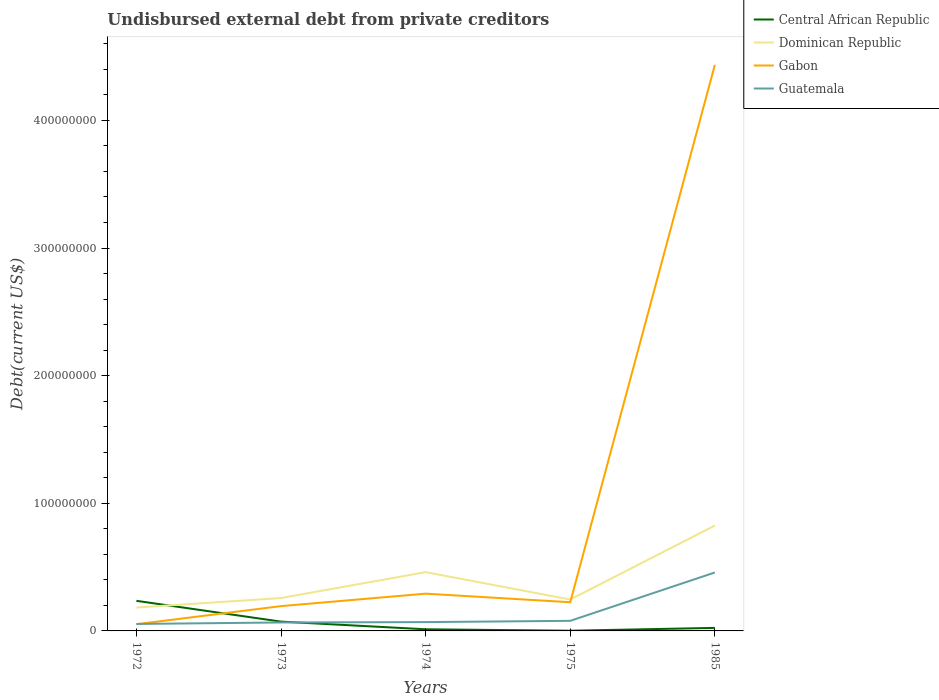Does the line corresponding to Central African Republic intersect with the line corresponding to Guatemala?
Make the answer very short. Yes. Across all years, what is the maximum total debt in Gabon?
Provide a short and direct response. 5.24e+06. What is the total total debt in Central African Republic in the graph?
Provide a short and direct response. 1.12e+06. What is the difference between the highest and the second highest total debt in Guatemala?
Offer a very short reply. 4.03e+07. What is the difference between the highest and the lowest total debt in Guatemala?
Your response must be concise. 1. Is the total debt in Central African Republic strictly greater than the total debt in Gabon over the years?
Ensure brevity in your answer.  No. How many lines are there?
Keep it short and to the point. 4. What is the difference between two consecutive major ticks on the Y-axis?
Provide a succinct answer. 1.00e+08. Does the graph contain grids?
Your response must be concise. No. Where does the legend appear in the graph?
Provide a succinct answer. Top right. How many legend labels are there?
Provide a succinct answer. 4. What is the title of the graph?
Provide a short and direct response. Undisbursed external debt from private creditors. Does "Central African Republic" appear as one of the legend labels in the graph?
Keep it short and to the point. Yes. What is the label or title of the Y-axis?
Your response must be concise. Debt(current US$). What is the Debt(current US$) of Central African Republic in 1972?
Your response must be concise. 2.36e+07. What is the Debt(current US$) in Dominican Republic in 1972?
Ensure brevity in your answer.  1.83e+07. What is the Debt(current US$) in Gabon in 1972?
Your answer should be very brief. 5.24e+06. What is the Debt(current US$) in Guatemala in 1972?
Provide a short and direct response. 5.46e+06. What is the Debt(current US$) of Central African Republic in 1973?
Provide a short and direct response. 7.28e+06. What is the Debt(current US$) in Dominican Republic in 1973?
Your answer should be compact. 2.58e+07. What is the Debt(current US$) of Gabon in 1973?
Offer a very short reply. 1.94e+07. What is the Debt(current US$) in Guatemala in 1973?
Offer a terse response. 6.62e+06. What is the Debt(current US$) in Central African Republic in 1974?
Provide a short and direct response. 1.28e+06. What is the Debt(current US$) of Dominican Republic in 1974?
Provide a short and direct response. 4.61e+07. What is the Debt(current US$) in Gabon in 1974?
Offer a terse response. 2.92e+07. What is the Debt(current US$) in Guatemala in 1974?
Make the answer very short. 6.90e+06. What is the Debt(current US$) in Central African Republic in 1975?
Give a very brief answer. 1.62e+05. What is the Debt(current US$) in Dominican Republic in 1975?
Keep it short and to the point. 2.46e+07. What is the Debt(current US$) in Gabon in 1975?
Offer a terse response. 2.25e+07. What is the Debt(current US$) in Guatemala in 1975?
Your answer should be very brief. 7.91e+06. What is the Debt(current US$) of Central African Republic in 1985?
Ensure brevity in your answer.  2.37e+06. What is the Debt(current US$) in Dominican Republic in 1985?
Ensure brevity in your answer.  8.26e+07. What is the Debt(current US$) in Gabon in 1985?
Keep it short and to the point. 4.44e+08. What is the Debt(current US$) of Guatemala in 1985?
Offer a very short reply. 4.58e+07. Across all years, what is the maximum Debt(current US$) of Central African Republic?
Ensure brevity in your answer.  2.36e+07. Across all years, what is the maximum Debt(current US$) of Dominican Republic?
Ensure brevity in your answer.  8.26e+07. Across all years, what is the maximum Debt(current US$) of Gabon?
Your response must be concise. 4.44e+08. Across all years, what is the maximum Debt(current US$) of Guatemala?
Provide a short and direct response. 4.58e+07. Across all years, what is the minimum Debt(current US$) in Central African Republic?
Give a very brief answer. 1.62e+05. Across all years, what is the minimum Debt(current US$) in Dominican Republic?
Make the answer very short. 1.83e+07. Across all years, what is the minimum Debt(current US$) of Gabon?
Keep it short and to the point. 5.24e+06. Across all years, what is the minimum Debt(current US$) of Guatemala?
Offer a terse response. 5.46e+06. What is the total Debt(current US$) of Central African Republic in the graph?
Keep it short and to the point. 3.47e+07. What is the total Debt(current US$) in Dominican Republic in the graph?
Ensure brevity in your answer.  1.97e+08. What is the total Debt(current US$) of Gabon in the graph?
Your answer should be very brief. 5.20e+08. What is the total Debt(current US$) in Guatemala in the graph?
Ensure brevity in your answer.  7.27e+07. What is the difference between the Debt(current US$) of Central African Republic in 1972 and that in 1973?
Offer a terse response. 1.63e+07. What is the difference between the Debt(current US$) of Dominican Republic in 1972 and that in 1973?
Give a very brief answer. -7.46e+06. What is the difference between the Debt(current US$) of Gabon in 1972 and that in 1973?
Your answer should be very brief. -1.42e+07. What is the difference between the Debt(current US$) in Guatemala in 1972 and that in 1973?
Your answer should be very brief. -1.16e+06. What is the difference between the Debt(current US$) of Central African Republic in 1972 and that in 1974?
Your answer should be compact. 2.23e+07. What is the difference between the Debt(current US$) in Dominican Republic in 1972 and that in 1974?
Your answer should be compact. -2.77e+07. What is the difference between the Debt(current US$) of Gabon in 1972 and that in 1974?
Ensure brevity in your answer.  -2.40e+07. What is the difference between the Debt(current US$) of Guatemala in 1972 and that in 1974?
Your response must be concise. -1.44e+06. What is the difference between the Debt(current US$) in Central African Republic in 1972 and that in 1975?
Keep it short and to the point. 2.34e+07. What is the difference between the Debt(current US$) in Dominican Republic in 1972 and that in 1975?
Your response must be concise. -6.30e+06. What is the difference between the Debt(current US$) of Gabon in 1972 and that in 1975?
Ensure brevity in your answer.  -1.72e+07. What is the difference between the Debt(current US$) in Guatemala in 1972 and that in 1975?
Ensure brevity in your answer.  -2.44e+06. What is the difference between the Debt(current US$) in Central African Republic in 1972 and that in 1985?
Offer a very short reply. 2.12e+07. What is the difference between the Debt(current US$) in Dominican Republic in 1972 and that in 1985?
Provide a short and direct response. -6.43e+07. What is the difference between the Debt(current US$) in Gabon in 1972 and that in 1985?
Offer a very short reply. -4.38e+08. What is the difference between the Debt(current US$) of Guatemala in 1972 and that in 1985?
Ensure brevity in your answer.  -4.03e+07. What is the difference between the Debt(current US$) of Central African Republic in 1973 and that in 1974?
Your answer should be compact. 6.00e+06. What is the difference between the Debt(current US$) of Dominican Republic in 1973 and that in 1974?
Make the answer very short. -2.03e+07. What is the difference between the Debt(current US$) of Gabon in 1973 and that in 1974?
Your answer should be compact. -9.76e+06. What is the difference between the Debt(current US$) in Guatemala in 1973 and that in 1974?
Your response must be concise. -2.82e+05. What is the difference between the Debt(current US$) of Central African Republic in 1973 and that in 1975?
Keep it short and to the point. 7.12e+06. What is the difference between the Debt(current US$) in Dominican Republic in 1973 and that in 1975?
Provide a short and direct response. 1.16e+06. What is the difference between the Debt(current US$) of Gabon in 1973 and that in 1975?
Your answer should be compact. -3.05e+06. What is the difference between the Debt(current US$) of Guatemala in 1973 and that in 1975?
Your answer should be very brief. -1.29e+06. What is the difference between the Debt(current US$) of Central African Republic in 1973 and that in 1985?
Your answer should be compact. 4.91e+06. What is the difference between the Debt(current US$) in Dominican Republic in 1973 and that in 1985?
Make the answer very short. -5.68e+07. What is the difference between the Debt(current US$) in Gabon in 1973 and that in 1985?
Provide a succinct answer. -4.24e+08. What is the difference between the Debt(current US$) in Guatemala in 1973 and that in 1985?
Provide a succinct answer. -3.92e+07. What is the difference between the Debt(current US$) in Central African Republic in 1974 and that in 1975?
Provide a succinct answer. 1.12e+06. What is the difference between the Debt(current US$) of Dominican Republic in 1974 and that in 1975?
Make the answer very short. 2.14e+07. What is the difference between the Debt(current US$) of Gabon in 1974 and that in 1975?
Provide a succinct answer. 6.71e+06. What is the difference between the Debt(current US$) of Guatemala in 1974 and that in 1975?
Your answer should be compact. -1.01e+06. What is the difference between the Debt(current US$) in Central African Republic in 1974 and that in 1985?
Provide a succinct answer. -1.09e+06. What is the difference between the Debt(current US$) in Dominican Republic in 1974 and that in 1985?
Give a very brief answer. -3.65e+07. What is the difference between the Debt(current US$) of Gabon in 1974 and that in 1985?
Make the answer very short. -4.14e+08. What is the difference between the Debt(current US$) of Guatemala in 1974 and that in 1985?
Make the answer very short. -3.89e+07. What is the difference between the Debt(current US$) in Central African Republic in 1975 and that in 1985?
Your response must be concise. -2.21e+06. What is the difference between the Debt(current US$) in Dominican Republic in 1975 and that in 1985?
Offer a very short reply. -5.80e+07. What is the difference between the Debt(current US$) of Gabon in 1975 and that in 1985?
Your answer should be very brief. -4.21e+08. What is the difference between the Debt(current US$) in Guatemala in 1975 and that in 1985?
Your answer should be very brief. -3.79e+07. What is the difference between the Debt(current US$) in Central African Republic in 1972 and the Debt(current US$) in Dominican Republic in 1973?
Offer a terse response. -2.19e+06. What is the difference between the Debt(current US$) in Central African Republic in 1972 and the Debt(current US$) in Gabon in 1973?
Offer a terse response. 4.15e+06. What is the difference between the Debt(current US$) of Central African Republic in 1972 and the Debt(current US$) of Guatemala in 1973?
Ensure brevity in your answer.  1.70e+07. What is the difference between the Debt(current US$) in Dominican Republic in 1972 and the Debt(current US$) in Gabon in 1973?
Make the answer very short. -1.12e+06. What is the difference between the Debt(current US$) in Dominican Republic in 1972 and the Debt(current US$) in Guatemala in 1973?
Ensure brevity in your answer.  1.17e+07. What is the difference between the Debt(current US$) in Gabon in 1972 and the Debt(current US$) in Guatemala in 1973?
Offer a very short reply. -1.38e+06. What is the difference between the Debt(current US$) in Central African Republic in 1972 and the Debt(current US$) in Dominican Republic in 1974?
Your answer should be compact. -2.25e+07. What is the difference between the Debt(current US$) in Central African Republic in 1972 and the Debt(current US$) in Gabon in 1974?
Your answer should be compact. -5.61e+06. What is the difference between the Debt(current US$) of Central African Republic in 1972 and the Debt(current US$) of Guatemala in 1974?
Ensure brevity in your answer.  1.67e+07. What is the difference between the Debt(current US$) in Dominican Republic in 1972 and the Debt(current US$) in Gabon in 1974?
Provide a succinct answer. -1.09e+07. What is the difference between the Debt(current US$) of Dominican Republic in 1972 and the Debt(current US$) of Guatemala in 1974?
Ensure brevity in your answer.  1.14e+07. What is the difference between the Debt(current US$) of Gabon in 1972 and the Debt(current US$) of Guatemala in 1974?
Ensure brevity in your answer.  -1.66e+06. What is the difference between the Debt(current US$) of Central African Republic in 1972 and the Debt(current US$) of Dominican Republic in 1975?
Give a very brief answer. -1.03e+06. What is the difference between the Debt(current US$) of Central African Republic in 1972 and the Debt(current US$) of Gabon in 1975?
Make the answer very short. 1.10e+06. What is the difference between the Debt(current US$) of Central African Republic in 1972 and the Debt(current US$) of Guatemala in 1975?
Make the answer very short. 1.57e+07. What is the difference between the Debt(current US$) of Dominican Republic in 1972 and the Debt(current US$) of Gabon in 1975?
Your answer should be very brief. -4.17e+06. What is the difference between the Debt(current US$) of Dominican Republic in 1972 and the Debt(current US$) of Guatemala in 1975?
Offer a very short reply. 1.04e+07. What is the difference between the Debt(current US$) of Gabon in 1972 and the Debt(current US$) of Guatemala in 1975?
Give a very brief answer. -2.66e+06. What is the difference between the Debt(current US$) in Central African Republic in 1972 and the Debt(current US$) in Dominican Republic in 1985?
Offer a terse response. -5.90e+07. What is the difference between the Debt(current US$) of Central African Republic in 1972 and the Debt(current US$) of Gabon in 1985?
Provide a succinct answer. -4.20e+08. What is the difference between the Debt(current US$) of Central African Republic in 1972 and the Debt(current US$) of Guatemala in 1985?
Your answer should be very brief. -2.22e+07. What is the difference between the Debt(current US$) of Dominican Republic in 1972 and the Debt(current US$) of Gabon in 1985?
Make the answer very short. -4.25e+08. What is the difference between the Debt(current US$) in Dominican Republic in 1972 and the Debt(current US$) in Guatemala in 1985?
Provide a short and direct response. -2.75e+07. What is the difference between the Debt(current US$) in Gabon in 1972 and the Debt(current US$) in Guatemala in 1985?
Your response must be concise. -4.05e+07. What is the difference between the Debt(current US$) in Central African Republic in 1973 and the Debt(current US$) in Dominican Republic in 1974?
Provide a succinct answer. -3.88e+07. What is the difference between the Debt(current US$) in Central African Republic in 1973 and the Debt(current US$) in Gabon in 1974?
Your answer should be compact. -2.19e+07. What is the difference between the Debt(current US$) of Central African Republic in 1973 and the Debt(current US$) of Guatemala in 1974?
Keep it short and to the point. 3.81e+05. What is the difference between the Debt(current US$) of Dominican Republic in 1973 and the Debt(current US$) of Gabon in 1974?
Keep it short and to the point. -3.42e+06. What is the difference between the Debt(current US$) of Dominican Republic in 1973 and the Debt(current US$) of Guatemala in 1974?
Make the answer very short. 1.89e+07. What is the difference between the Debt(current US$) in Gabon in 1973 and the Debt(current US$) in Guatemala in 1974?
Make the answer very short. 1.25e+07. What is the difference between the Debt(current US$) of Central African Republic in 1973 and the Debt(current US$) of Dominican Republic in 1975?
Your response must be concise. -1.73e+07. What is the difference between the Debt(current US$) of Central African Republic in 1973 and the Debt(current US$) of Gabon in 1975?
Your answer should be compact. -1.52e+07. What is the difference between the Debt(current US$) of Central African Republic in 1973 and the Debt(current US$) of Guatemala in 1975?
Provide a succinct answer. -6.26e+05. What is the difference between the Debt(current US$) of Dominican Republic in 1973 and the Debt(current US$) of Gabon in 1975?
Keep it short and to the point. 3.29e+06. What is the difference between the Debt(current US$) in Dominican Republic in 1973 and the Debt(current US$) in Guatemala in 1975?
Offer a very short reply. 1.79e+07. What is the difference between the Debt(current US$) in Gabon in 1973 and the Debt(current US$) in Guatemala in 1975?
Give a very brief answer. 1.15e+07. What is the difference between the Debt(current US$) in Central African Republic in 1973 and the Debt(current US$) in Dominican Republic in 1985?
Make the answer very short. -7.53e+07. What is the difference between the Debt(current US$) of Central African Republic in 1973 and the Debt(current US$) of Gabon in 1985?
Give a very brief answer. -4.36e+08. What is the difference between the Debt(current US$) in Central African Republic in 1973 and the Debt(current US$) in Guatemala in 1985?
Your answer should be compact. -3.85e+07. What is the difference between the Debt(current US$) of Dominican Republic in 1973 and the Debt(current US$) of Gabon in 1985?
Your answer should be compact. -4.18e+08. What is the difference between the Debt(current US$) of Dominican Republic in 1973 and the Debt(current US$) of Guatemala in 1985?
Give a very brief answer. -2.00e+07. What is the difference between the Debt(current US$) of Gabon in 1973 and the Debt(current US$) of Guatemala in 1985?
Your answer should be compact. -2.64e+07. What is the difference between the Debt(current US$) in Central African Republic in 1974 and the Debt(current US$) in Dominican Republic in 1975?
Offer a terse response. -2.33e+07. What is the difference between the Debt(current US$) in Central African Republic in 1974 and the Debt(current US$) in Gabon in 1975?
Your answer should be compact. -2.12e+07. What is the difference between the Debt(current US$) of Central African Republic in 1974 and the Debt(current US$) of Guatemala in 1975?
Your response must be concise. -6.62e+06. What is the difference between the Debt(current US$) in Dominican Republic in 1974 and the Debt(current US$) in Gabon in 1975?
Provide a short and direct response. 2.36e+07. What is the difference between the Debt(current US$) in Dominican Republic in 1974 and the Debt(current US$) in Guatemala in 1975?
Your answer should be compact. 3.81e+07. What is the difference between the Debt(current US$) in Gabon in 1974 and the Debt(current US$) in Guatemala in 1975?
Your answer should be very brief. 2.13e+07. What is the difference between the Debt(current US$) of Central African Republic in 1974 and the Debt(current US$) of Dominican Republic in 1985?
Give a very brief answer. -8.13e+07. What is the difference between the Debt(current US$) of Central African Republic in 1974 and the Debt(current US$) of Gabon in 1985?
Ensure brevity in your answer.  -4.42e+08. What is the difference between the Debt(current US$) of Central African Republic in 1974 and the Debt(current US$) of Guatemala in 1985?
Your answer should be very brief. -4.45e+07. What is the difference between the Debt(current US$) in Dominican Republic in 1974 and the Debt(current US$) in Gabon in 1985?
Make the answer very short. -3.97e+08. What is the difference between the Debt(current US$) in Dominican Republic in 1974 and the Debt(current US$) in Guatemala in 1985?
Keep it short and to the point. 2.63e+05. What is the difference between the Debt(current US$) in Gabon in 1974 and the Debt(current US$) in Guatemala in 1985?
Give a very brief answer. -1.66e+07. What is the difference between the Debt(current US$) of Central African Republic in 1975 and the Debt(current US$) of Dominican Republic in 1985?
Offer a terse response. -8.24e+07. What is the difference between the Debt(current US$) of Central African Republic in 1975 and the Debt(current US$) of Gabon in 1985?
Your answer should be very brief. -4.43e+08. What is the difference between the Debt(current US$) in Central African Republic in 1975 and the Debt(current US$) in Guatemala in 1985?
Offer a very short reply. -4.56e+07. What is the difference between the Debt(current US$) in Dominican Republic in 1975 and the Debt(current US$) in Gabon in 1985?
Your answer should be compact. -4.19e+08. What is the difference between the Debt(current US$) of Dominican Republic in 1975 and the Debt(current US$) of Guatemala in 1985?
Ensure brevity in your answer.  -2.12e+07. What is the difference between the Debt(current US$) of Gabon in 1975 and the Debt(current US$) of Guatemala in 1985?
Ensure brevity in your answer.  -2.33e+07. What is the average Debt(current US$) of Central African Republic per year?
Offer a terse response. 6.94e+06. What is the average Debt(current US$) in Dominican Republic per year?
Offer a very short reply. 3.95e+07. What is the average Debt(current US$) of Gabon per year?
Offer a very short reply. 1.04e+08. What is the average Debt(current US$) in Guatemala per year?
Offer a terse response. 1.45e+07. In the year 1972, what is the difference between the Debt(current US$) of Central African Republic and Debt(current US$) of Dominican Republic?
Your answer should be very brief. 5.27e+06. In the year 1972, what is the difference between the Debt(current US$) of Central African Republic and Debt(current US$) of Gabon?
Offer a very short reply. 1.83e+07. In the year 1972, what is the difference between the Debt(current US$) of Central African Republic and Debt(current US$) of Guatemala?
Ensure brevity in your answer.  1.81e+07. In the year 1972, what is the difference between the Debt(current US$) of Dominican Republic and Debt(current US$) of Gabon?
Provide a short and direct response. 1.31e+07. In the year 1972, what is the difference between the Debt(current US$) in Dominican Republic and Debt(current US$) in Guatemala?
Keep it short and to the point. 1.29e+07. In the year 1973, what is the difference between the Debt(current US$) of Central African Republic and Debt(current US$) of Dominican Republic?
Your answer should be very brief. -1.85e+07. In the year 1973, what is the difference between the Debt(current US$) in Central African Republic and Debt(current US$) in Gabon?
Provide a short and direct response. -1.22e+07. In the year 1973, what is the difference between the Debt(current US$) of Central African Republic and Debt(current US$) of Guatemala?
Keep it short and to the point. 6.63e+05. In the year 1973, what is the difference between the Debt(current US$) in Dominican Republic and Debt(current US$) in Gabon?
Offer a terse response. 6.34e+06. In the year 1973, what is the difference between the Debt(current US$) in Dominican Republic and Debt(current US$) in Guatemala?
Your answer should be compact. 1.92e+07. In the year 1973, what is the difference between the Debt(current US$) of Gabon and Debt(current US$) of Guatemala?
Offer a terse response. 1.28e+07. In the year 1974, what is the difference between the Debt(current US$) in Central African Republic and Debt(current US$) in Dominican Republic?
Give a very brief answer. -4.48e+07. In the year 1974, what is the difference between the Debt(current US$) of Central African Republic and Debt(current US$) of Gabon?
Ensure brevity in your answer.  -2.79e+07. In the year 1974, what is the difference between the Debt(current US$) in Central African Republic and Debt(current US$) in Guatemala?
Your answer should be very brief. -5.62e+06. In the year 1974, what is the difference between the Debt(current US$) in Dominican Republic and Debt(current US$) in Gabon?
Ensure brevity in your answer.  1.69e+07. In the year 1974, what is the difference between the Debt(current US$) of Dominican Republic and Debt(current US$) of Guatemala?
Ensure brevity in your answer.  3.91e+07. In the year 1974, what is the difference between the Debt(current US$) in Gabon and Debt(current US$) in Guatemala?
Give a very brief answer. 2.23e+07. In the year 1975, what is the difference between the Debt(current US$) of Central African Republic and Debt(current US$) of Dominican Republic?
Your answer should be very brief. -2.44e+07. In the year 1975, what is the difference between the Debt(current US$) in Central African Republic and Debt(current US$) in Gabon?
Your response must be concise. -2.23e+07. In the year 1975, what is the difference between the Debt(current US$) of Central African Republic and Debt(current US$) of Guatemala?
Make the answer very short. -7.75e+06. In the year 1975, what is the difference between the Debt(current US$) of Dominican Republic and Debt(current US$) of Gabon?
Offer a terse response. 2.13e+06. In the year 1975, what is the difference between the Debt(current US$) in Dominican Republic and Debt(current US$) in Guatemala?
Ensure brevity in your answer.  1.67e+07. In the year 1975, what is the difference between the Debt(current US$) in Gabon and Debt(current US$) in Guatemala?
Offer a terse response. 1.46e+07. In the year 1985, what is the difference between the Debt(current US$) in Central African Republic and Debt(current US$) in Dominican Republic?
Provide a short and direct response. -8.02e+07. In the year 1985, what is the difference between the Debt(current US$) of Central African Republic and Debt(current US$) of Gabon?
Offer a terse response. -4.41e+08. In the year 1985, what is the difference between the Debt(current US$) of Central African Republic and Debt(current US$) of Guatemala?
Offer a very short reply. -4.34e+07. In the year 1985, what is the difference between the Debt(current US$) of Dominican Republic and Debt(current US$) of Gabon?
Offer a terse response. -3.61e+08. In the year 1985, what is the difference between the Debt(current US$) of Dominican Republic and Debt(current US$) of Guatemala?
Offer a terse response. 3.68e+07. In the year 1985, what is the difference between the Debt(current US$) of Gabon and Debt(current US$) of Guatemala?
Give a very brief answer. 3.98e+08. What is the ratio of the Debt(current US$) of Central African Republic in 1972 to that in 1973?
Your answer should be compact. 3.24. What is the ratio of the Debt(current US$) of Dominican Republic in 1972 to that in 1973?
Offer a terse response. 0.71. What is the ratio of the Debt(current US$) in Gabon in 1972 to that in 1973?
Give a very brief answer. 0.27. What is the ratio of the Debt(current US$) of Guatemala in 1972 to that in 1973?
Keep it short and to the point. 0.83. What is the ratio of the Debt(current US$) in Central African Republic in 1972 to that in 1974?
Provide a short and direct response. 18.35. What is the ratio of the Debt(current US$) in Dominican Republic in 1972 to that in 1974?
Give a very brief answer. 0.4. What is the ratio of the Debt(current US$) of Gabon in 1972 to that in 1974?
Offer a terse response. 0.18. What is the ratio of the Debt(current US$) of Guatemala in 1972 to that in 1974?
Provide a short and direct response. 0.79. What is the ratio of the Debt(current US$) of Central African Republic in 1972 to that in 1975?
Your answer should be very brief. 145.59. What is the ratio of the Debt(current US$) of Dominican Republic in 1972 to that in 1975?
Provide a short and direct response. 0.74. What is the ratio of the Debt(current US$) of Gabon in 1972 to that in 1975?
Provide a succinct answer. 0.23. What is the ratio of the Debt(current US$) in Guatemala in 1972 to that in 1975?
Give a very brief answer. 0.69. What is the ratio of the Debt(current US$) in Central African Republic in 1972 to that in 1985?
Offer a very short reply. 9.94. What is the ratio of the Debt(current US$) in Dominican Republic in 1972 to that in 1985?
Provide a succinct answer. 0.22. What is the ratio of the Debt(current US$) in Gabon in 1972 to that in 1985?
Your answer should be compact. 0.01. What is the ratio of the Debt(current US$) of Guatemala in 1972 to that in 1985?
Provide a succinct answer. 0.12. What is the ratio of the Debt(current US$) of Central African Republic in 1973 to that in 1974?
Give a very brief answer. 5.67. What is the ratio of the Debt(current US$) in Dominican Republic in 1973 to that in 1974?
Offer a terse response. 0.56. What is the ratio of the Debt(current US$) of Gabon in 1973 to that in 1974?
Ensure brevity in your answer.  0.67. What is the ratio of the Debt(current US$) of Guatemala in 1973 to that in 1974?
Make the answer very short. 0.96. What is the ratio of the Debt(current US$) of Central African Republic in 1973 to that in 1975?
Keep it short and to the point. 44.96. What is the ratio of the Debt(current US$) of Dominican Republic in 1973 to that in 1975?
Ensure brevity in your answer.  1.05. What is the ratio of the Debt(current US$) of Gabon in 1973 to that in 1975?
Offer a terse response. 0.86. What is the ratio of the Debt(current US$) in Guatemala in 1973 to that in 1975?
Your response must be concise. 0.84. What is the ratio of the Debt(current US$) in Central African Republic in 1973 to that in 1985?
Offer a terse response. 3.07. What is the ratio of the Debt(current US$) of Dominican Republic in 1973 to that in 1985?
Your answer should be compact. 0.31. What is the ratio of the Debt(current US$) in Gabon in 1973 to that in 1985?
Your answer should be compact. 0.04. What is the ratio of the Debt(current US$) in Guatemala in 1973 to that in 1985?
Keep it short and to the point. 0.14. What is the ratio of the Debt(current US$) of Central African Republic in 1974 to that in 1975?
Offer a very short reply. 7.93. What is the ratio of the Debt(current US$) of Dominican Republic in 1974 to that in 1975?
Offer a terse response. 1.87. What is the ratio of the Debt(current US$) of Gabon in 1974 to that in 1975?
Ensure brevity in your answer.  1.3. What is the ratio of the Debt(current US$) of Guatemala in 1974 to that in 1975?
Your answer should be very brief. 0.87. What is the ratio of the Debt(current US$) of Central African Republic in 1974 to that in 1985?
Ensure brevity in your answer.  0.54. What is the ratio of the Debt(current US$) of Dominican Republic in 1974 to that in 1985?
Your response must be concise. 0.56. What is the ratio of the Debt(current US$) of Gabon in 1974 to that in 1985?
Your answer should be very brief. 0.07. What is the ratio of the Debt(current US$) in Guatemala in 1974 to that in 1985?
Your answer should be very brief. 0.15. What is the ratio of the Debt(current US$) of Central African Republic in 1975 to that in 1985?
Provide a succinct answer. 0.07. What is the ratio of the Debt(current US$) in Dominican Republic in 1975 to that in 1985?
Your answer should be very brief. 0.3. What is the ratio of the Debt(current US$) in Gabon in 1975 to that in 1985?
Offer a very short reply. 0.05. What is the ratio of the Debt(current US$) in Guatemala in 1975 to that in 1985?
Your answer should be very brief. 0.17. What is the difference between the highest and the second highest Debt(current US$) in Central African Republic?
Ensure brevity in your answer.  1.63e+07. What is the difference between the highest and the second highest Debt(current US$) in Dominican Republic?
Offer a very short reply. 3.65e+07. What is the difference between the highest and the second highest Debt(current US$) in Gabon?
Ensure brevity in your answer.  4.14e+08. What is the difference between the highest and the second highest Debt(current US$) of Guatemala?
Your answer should be very brief. 3.79e+07. What is the difference between the highest and the lowest Debt(current US$) of Central African Republic?
Provide a short and direct response. 2.34e+07. What is the difference between the highest and the lowest Debt(current US$) in Dominican Republic?
Your response must be concise. 6.43e+07. What is the difference between the highest and the lowest Debt(current US$) in Gabon?
Offer a terse response. 4.38e+08. What is the difference between the highest and the lowest Debt(current US$) of Guatemala?
Your answer should be very brief. 4.03e+07. 